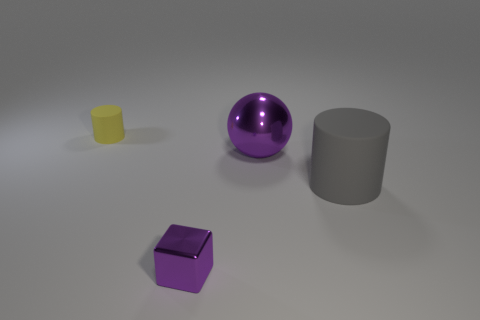Does the setting suggest a particular use for these objects? The setting doesn't suggest a specific use for the objects; rather, it seems to be a neutral space, maybe for display or instructional purposes. The plain background and uniform lighting are typical for visualizing objects clearly without any context or distraction. 